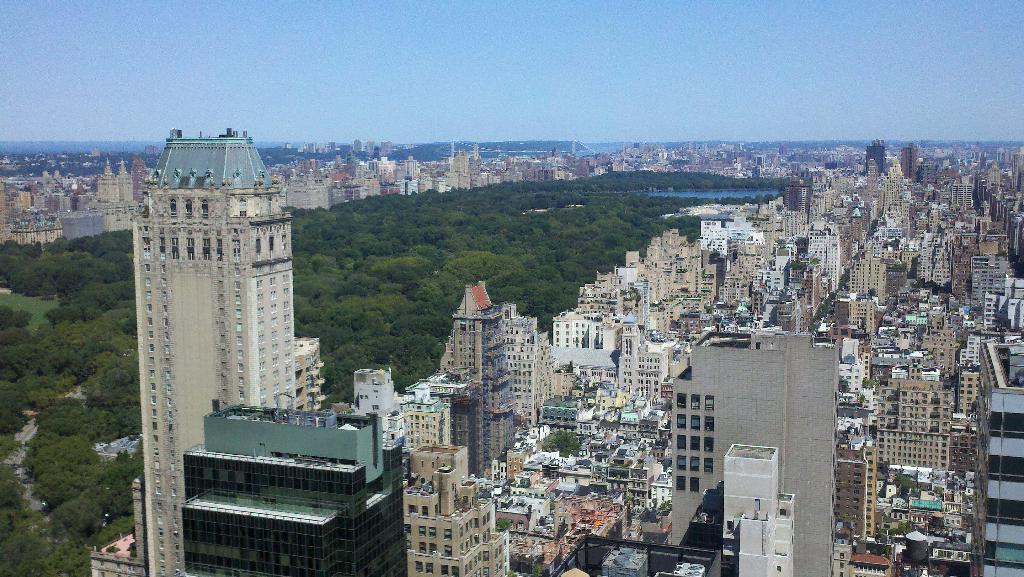Can you describe this image briefly? This is the aerial view image of a city, there are buildings on either side with trees in the middle and above its sky. 